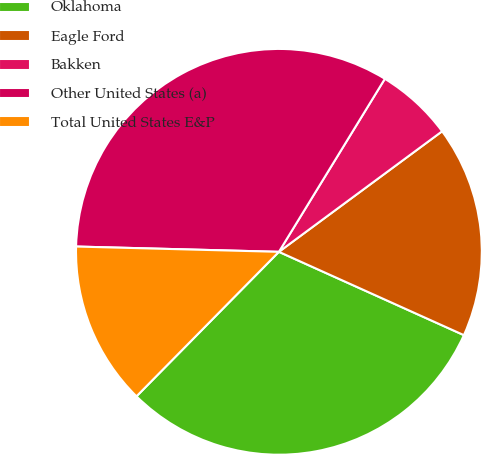<chart> <loc_0><loc_0><loc_500><loc_500><pie_chart><fcel>Oklahoma<fcel>Eagle Ford<fcel>Bakken<fcel>Other United States (a)<fcel>Total United States E&P<nl><fcel>30.65%<fcel>16.86%<fcel>6.13%<fcel>33.33%<fcel>13.03%<nl></chart> 